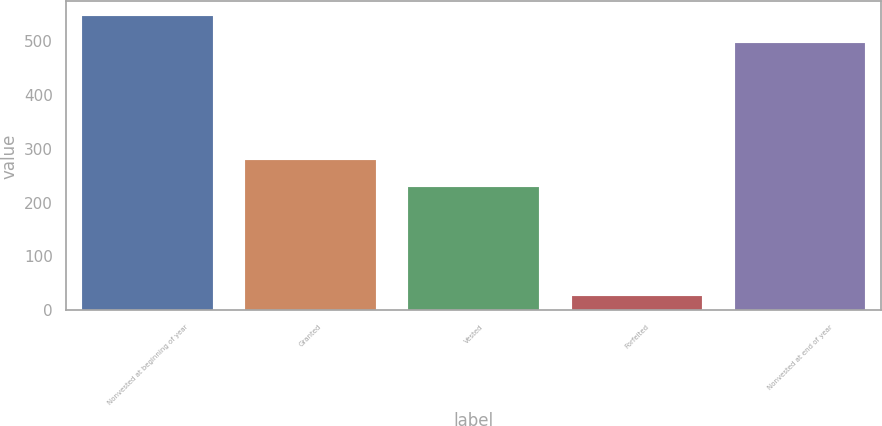Convert chart to OTSL. <chart><loc_0><loc_0><loc_500><loc_500><bar_chart><fcel>Nonvested at beginning of year<fcel>Granted<fcel>Vested<fcel>Forfeited<fcel>Nonvested at end of year<nl><fcel>545.4<fcel>278.4<fcel>229<fcel>27<fcel>496<nl></chart> 